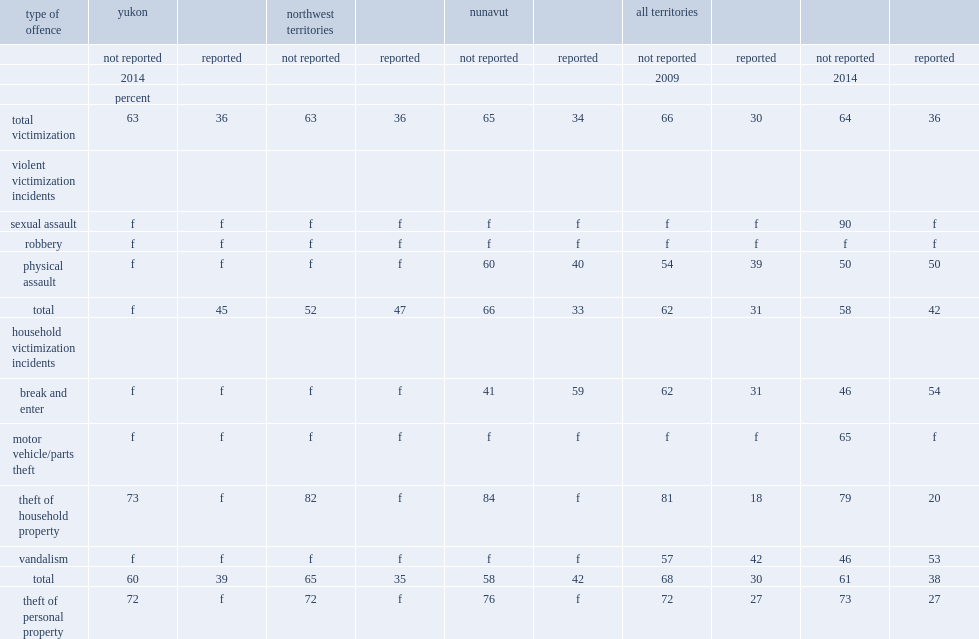What percentage of criminal incidents in the territories were reported to the police in 2009? 30.0. What percentage of criminal incidents in the territories were reported to the police in 2014? 36.0. What percentage of household victimization in the territories were reported to the police in 2009? 30.0. What percentage of household victimization in the territories were reported to the police in 2014? 38.0. What percentage of violent victimization incidents in the in the territories were reported to the police in 2009? 31.0. What percentage of violent victimization incidents in the in the territories were reported to the police in 2014? 42.0. 